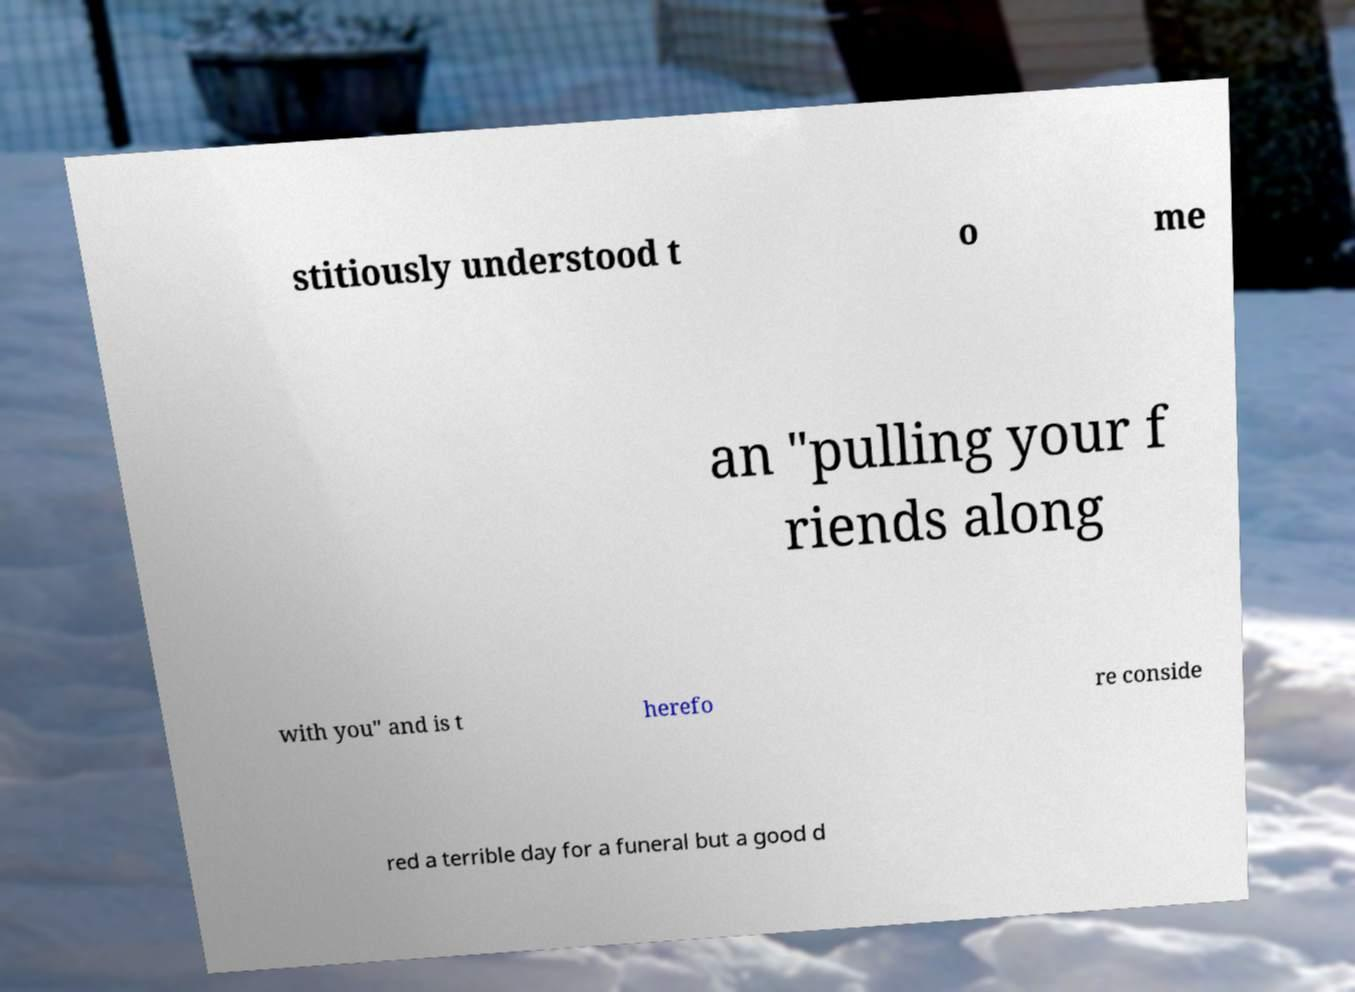Please read and relay the text visible in this image. What does it say? stitiously understood t o me an "pulling your f riends along with you" and is t herefo re conside red a terrible day for a funeral but a good d 